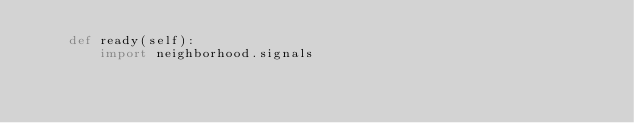Convert code to text. <code><loc_0><loc_0><loc_500><loc_500><_Python_>    def ready(self):
        import neighborhood.signals</code> 